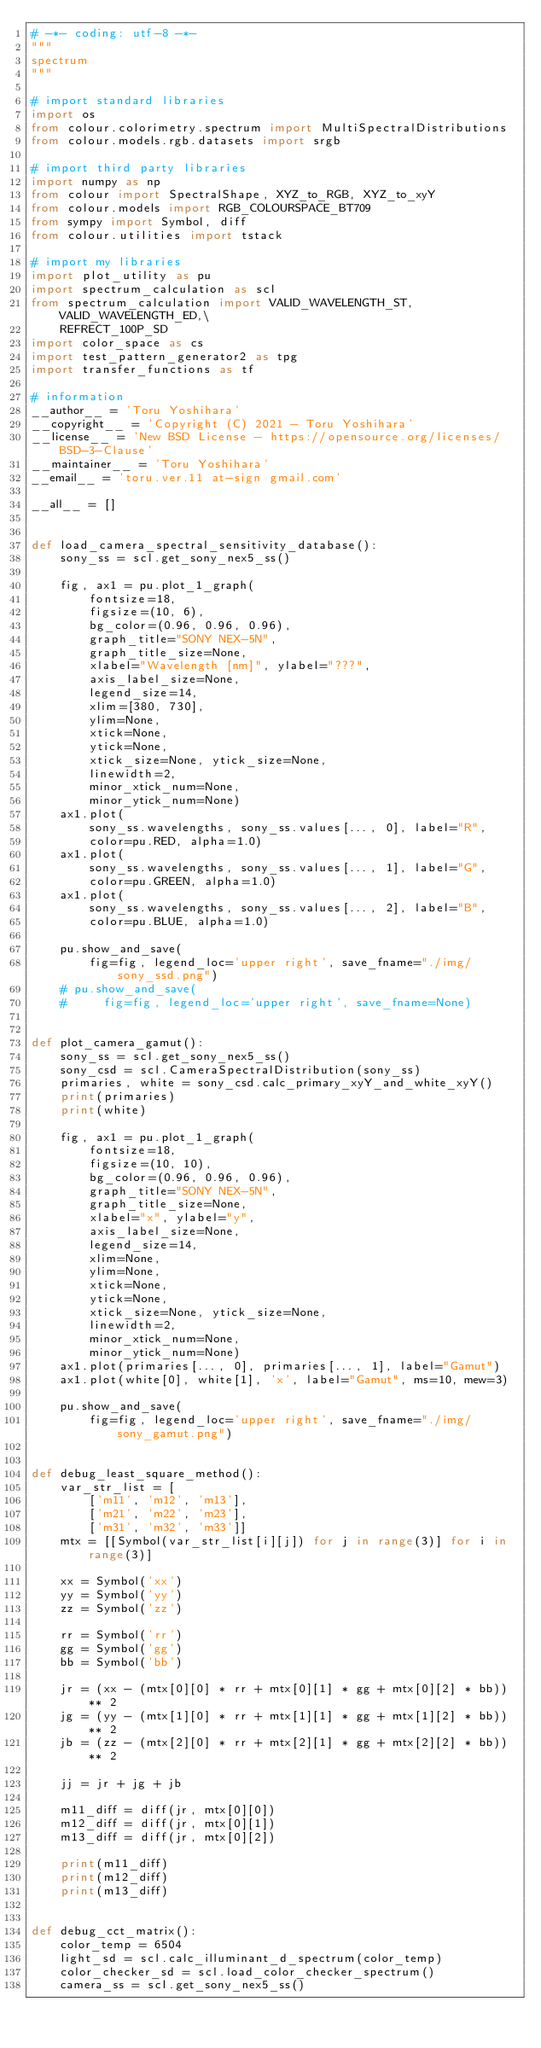<code> <loc_0><loc_0><loc_500><loc_500><_Python_># -*- coding: utf-8 -*-
"""
spectrum
"""

# import standard libraries
import os
from colour.colorimetry.spectrum import MultiSpectralDistributions
from colour.models.rgb.datasets import srgb

# import third party libraries
import numpy as np
from colour import SpectralShape, XYZ_to_RGB, XYZ_to_xyY
from colour.models import RGB_COLOURSPACE_BT709
from sympy import Symbol, diff
from colour.utilities import tstack

# import my libraries
import plot_utility as pu
import spectrum_calculation as scl
from spectrum_calculation import VALID_WAVELENGTH_ST, VALID_WAVELENGTH_ED,\
    REFRECT_100P_SD
import color_space as cs
import test_pattern_generator2 as tpg
import transfer_functions as tf

# information
__author__ = 'Toru Yoshihara'
__copyright__ = 'Copyright (C) 2021 - Toru Yoshihara'
__license__ = 'New BSD License - https://opensource.org/licenses/BSD-3-Clause'
__maintainer__ = 'Toru Yoshihara'
__email__ = 'toru.ver.11 at-sign gmail.com'

__all__ = []


def load_camera_spectral_sensitivity_database():
    sony_ss = scl.get_sony_nex5_ss()

    fig, ax1 = pu.plot_1_graph(
        fontsize=18,
        figsize=(10, 6),
        bg_color=(0.96, 0.96, 0.96),
        graph_title="SONY NEX-5N",
        graph_title_size=None,
        xlabel="Wavelength [nm]", ylabel="???",
        axis_label_size=None,
        legend_size=14,
        xlim=[380, 730],
        ylim=None,
        xtick=None,
        ytick=None,
        xtick_size=None, ytick_size=None,
        linewidth=2,
        minor_xtick_num=None,
        minor_ytick_num=None)
    ax1.plot(
        sony_ss.wavelengths, sony_ss.values[..., 0], label="R",
        color=pu.RED, alpha=1.0)
    ax1.plot(
        sony_ss.wavelengths, sony_ss.values[..., 1], label="G",
        color=pu.GREEN, alpha=1.0)
    ax1.plot(
        sony_ss.wavelengths, sony_ss.values[..., 2], label="B",
        color=pu.BLUE, alpha=1.0)

    pu.show_and_save(
        fig=fig, legend_loc='upper right', save_fname="./img/sony_ssd.png")
    # pu.show_and_save(
    #     fig=fig, legend_loc='upper right', save_fname=None)


def plot_camera_gamut():
    sony_ss = scl.get_sony_nex5_ss()
    sony_csd = scl.CameraSpectralDistribution(sony_ss)
    primaries, white = sony_csd.calc_primary_xyY_and_white_xyY()
    print(primaries)
    print(white)

    fig, ax1 = pu.plot_1_graph(
        fontsize=18,
        figsize=(10, 10),
        bg_color=(0.96, 0.96, 0.96),
        graph_title="SONY NEX-5N",
        graph_title_size=None,
        xlabel="x", ylabel="y",
        axis_label_size=None,
        legend_size=14,
        xlim=None,
        ylim=None,
        xtick=None,
        ytick=None,
        xtick_size=None, ytick_size=None,
        linewidth=2,
        minor_xtick_num=None,
        minor_ytick_num=None)
    ax1.plot(primaries[..., 0], primaries[..., 1], label="Gamut")
    ax1.plot(white[0], white[1], 'x', label="Gamut", ms=10, mew=3)

    pu.show_and_save(
        fig=fig, legend_loc='upper right', save_fname="./img/sony_gamut.png")


def debug_least_square_method():
    var_str_list = [
        ['m11', 'm12', 'm13'],
        ['m21', 'm22', 'm23'],
        ['m31', 'm32', 'm33']]
    mtx = [[Symbol(var_str_list[i][j]) for j in range(3)] for i in range(3)]

    xx = Symbol('xx')
    yy = Symbol('yy')
    zz = Symbol('zz')

    rr = Symbol('rr')
    gg = Symbol('gg')
    bb = Symbol('bb')

    jr = (xx - (mtx[0][0] * rr + mtx[0][1] * gg + mtx[0][2] * bb)) ** 2
    jg = (yy - (mtx[1][0] * rr + mtx[1][1] * gg + mtx[1][2] * bb)) ** 2
    jb = (zz - (mtx[2][0] * rr + mtx[2][1] * gg + mtx[2][2] * bb)) ** 2

    jj = jr + jg + jb

    m11_diff = diff(jr, mtx[0][0])
    m12_diff = diff(jr, mtx[0][1])
    m13_diff = diff(jr, mtx[0][2])

    print(m11_diff)
    print(m12_diff)
    print(m13_diff)


def debug_cct_matrix():
    color_temp = 6504
    light_sd = scl.calc_illuminant_d_spectrum(color_temp)
    color_checker_sd = scl.load_color_checker_spectrum()
    camera_ss = scl.get_sony_nex5_ss()</code> 